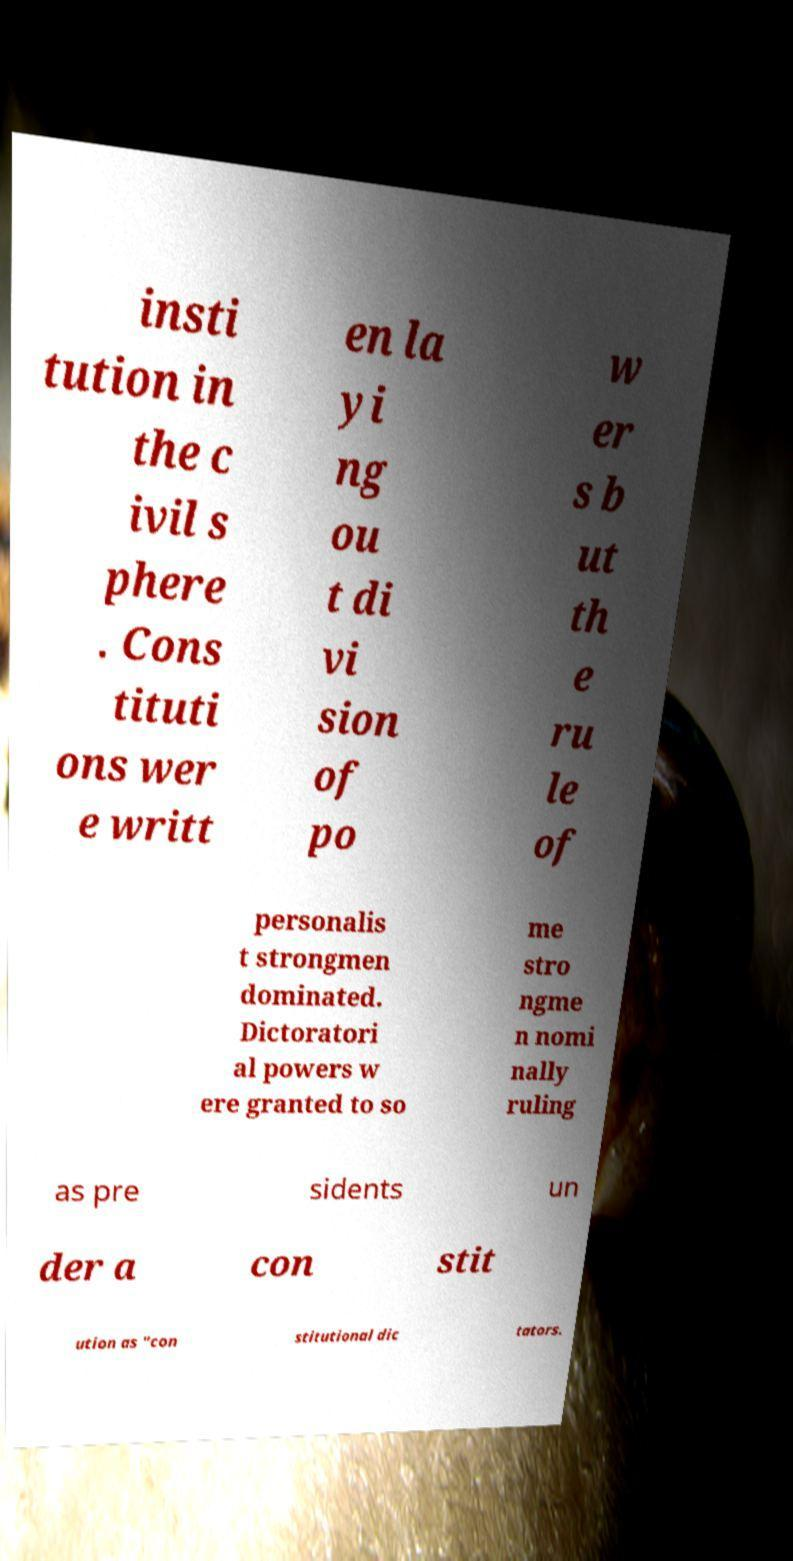Could you assist in decoding the text presented in this image and type it out clearly? insti tution in the c ivil s phere . Cons tituti ons wer e writt en la yi ng ou t di vi sion of po w er s b ut th e ru le of personalis t strongmen dominated. Dictoratori al powers w ere granted to so me stro ngme n nomi nally ruling as pre sidents un der a con stit ution as "con stitutional dic tators. 